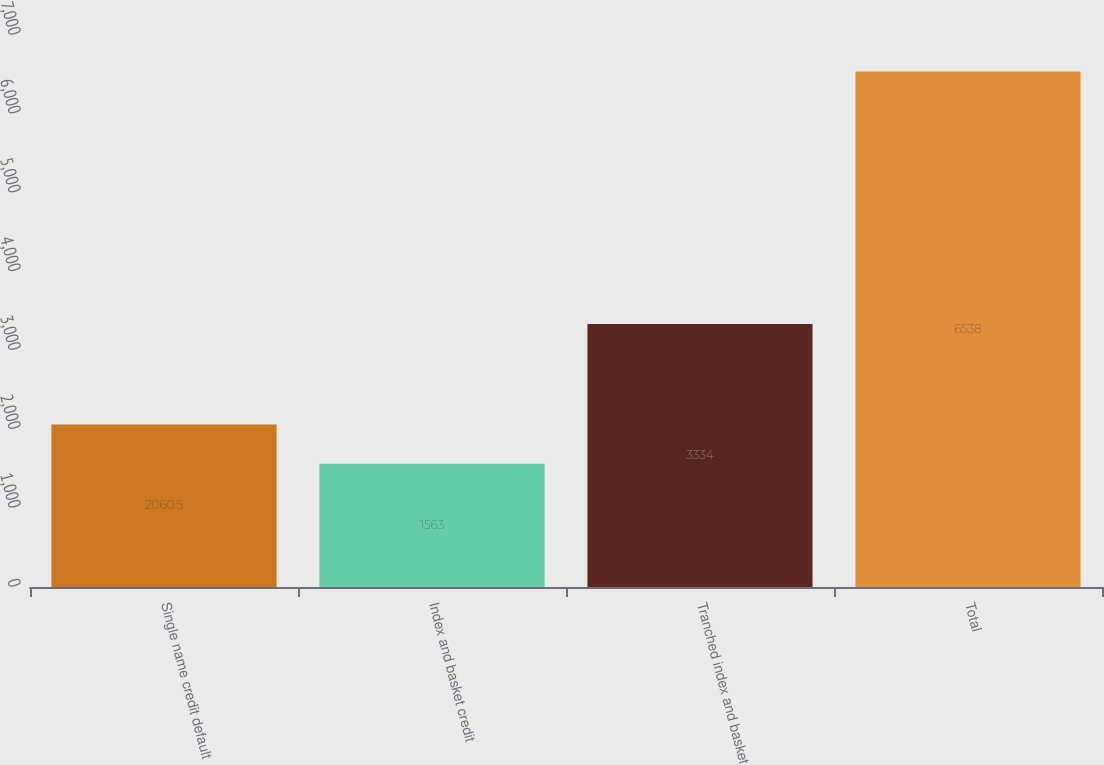Convert chart to OTSL. <chart><loc_0><loc_0><loc_500><loc_500><bar_chart><fcel>Single name credit default<fcel>Index and basket credit<fcel>Tranched index and basket<fcel>Total<nl><fcel>2060.5<fcel>1563<fcel>3334<fcel>6538<nl></chart> 